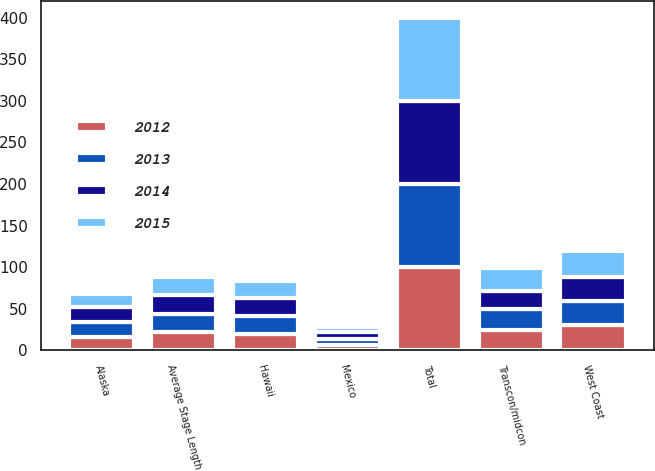Convert chart to OTSL. <chart><loc_0><loc_0><loc_500><loc_500><stacked_bar_chart><ecel><fcel>West Coast<fcel>Transcon/midcon<fcel>Hawaii<fcel>Alaska<fcel>Mexico<fcel>Total<fcel>Average Stage Length<nl><fcel>2015<fcel>31<fcel>27<fcel>20<fcel>16<fcel>6<fcel>100<fcel>22<nl><fcel>2012<fcel>31<fcel>25<fcel>20<fcel>16<fcel>7<fcel>100<fcel>22<nl><fcel>2013<fcel>28<fcel>25<fcel>21<fcel>18<fcel>7<fcel>100<fcel>22<nl><fcel>2014<fcel>29<fcel>22<fcel>22<fcel>18<fcel>8<fcel>100<fcel>22<nl></chart> 